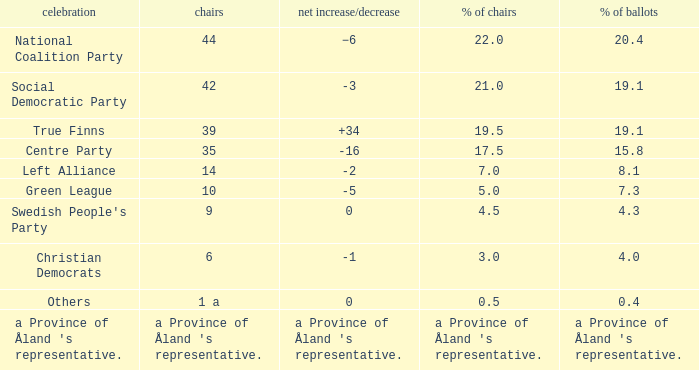Which party has a net gain/loss of -2? Left Alliance. Help me parse the entirety of this table. {'header': ['celebration', 'chairs', 'net increase/decrease', '% of chairs', '% of ballots'], 'rows': [['National Coalition Party', '44', '−6', '22.0', '20.4'], ['Social Democratic Party', '42', '-3', '21.0', '19.1'], ['True Finns', '39', '+34', '19.5', '19.1'], ['Centre Party', '35', '-16', '17.5', '15.8'], ['Left Alliance', '14', '-2', '7.0', '8.1'], ['Green League', '10', '-5', '5.0', '7.3'], ["Swedish People's Party", '9', '0', '4.5', '4.3'], ['Christian Democrats', '6', '-1', '3.0', '4.0'], ['Others', '1 a', '0', '0.5', '0.4'], ["a Province of Åland 's representative.", "a Province of Åland 's representative.", "a Province of Åland 's representative.", "a Province of Åland 's representative.", "a Province of Åland 's representative."]]} 